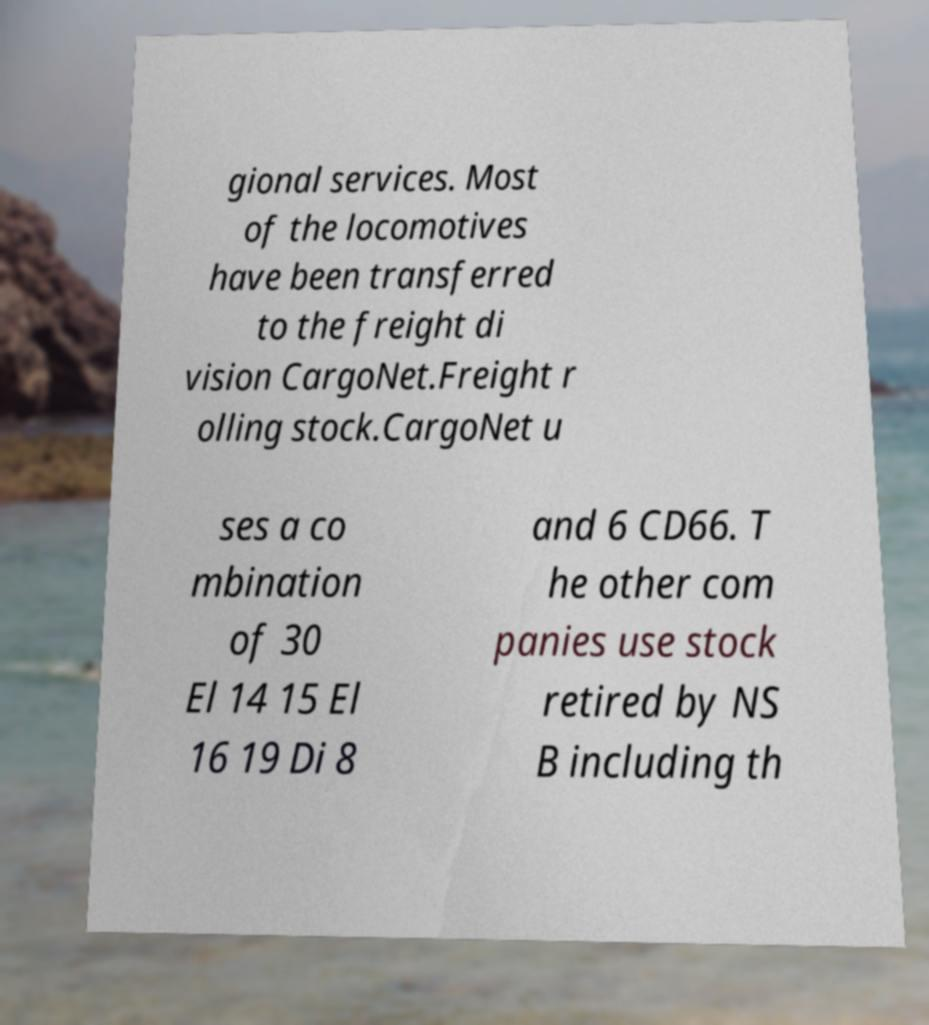For documentation purposes, I need the text within this image transcribed. Could you provide that? gional services. Most of the locomotives have been transferred to the freight di vision CargoNet.Freight r olling stock.CargoNet u ses a co mbination of 30 El 14 15 El 16 19 Di 8 and 6 CD66. T he other com panies use stock retired by NS B including th 